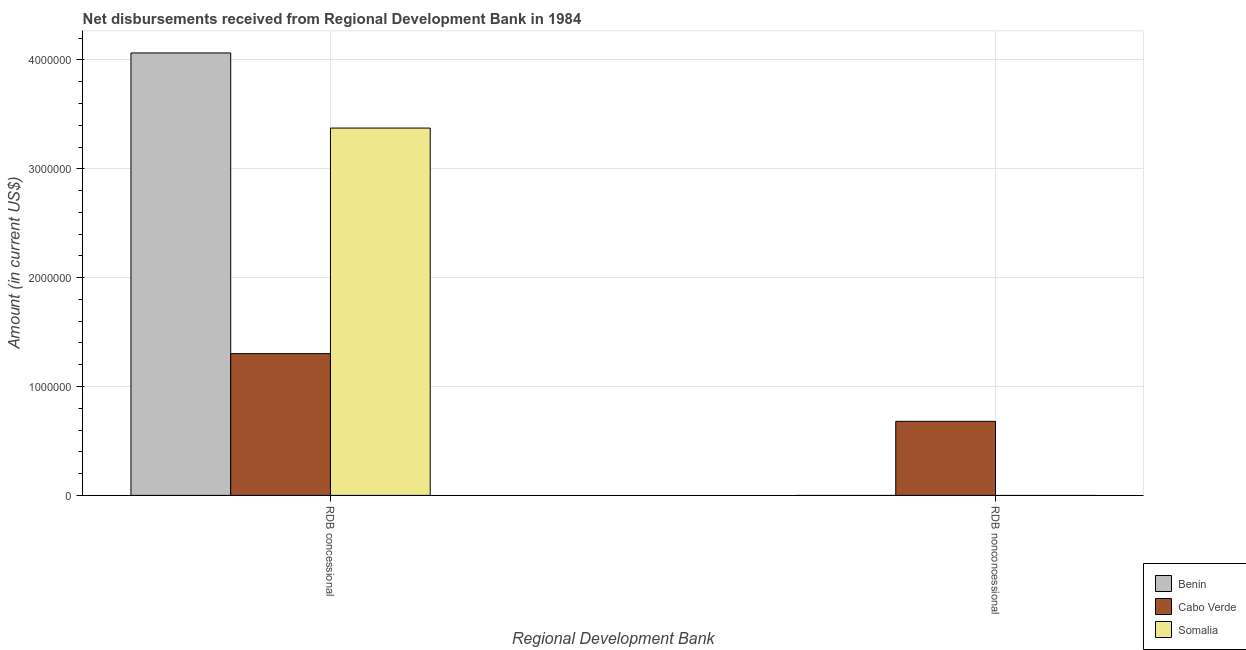How many different coloured bars are there?
Give a very brief answer. 3. Are the number of bars on each tick of the X-axis equal?
Offer a terse response. No. How many bars are there on the 1st tick from the left?
Your answer should be compact. 3. How many bars are there on the 2nd tick from the right?
Offer a very short reply. 3. What is the label of the 2nd group of bars from the left?
Offer a very short reply. RDB nonconcessional. What is the net non concessional disbursements from rdb in Cabo Verde?
Give a very brief answer. 6.80e+05. Across all countries, what is the maximum net concessional disbursements from rdb?
Offer a terse response. 4.06e+06. Across all countries, what is the minimum net concessional disbursements from rdb?
Offer a terse response. 1.30e+06. In which country was the net non concessional disbursements from rdb maximum?
Your answer should be very brief. Cabo Verde. What is the total net non concessional disbursements from rdb in the graph?
Offer a very short reply. 6.80e+05. What is the difference between the net concessional disbursements from rdb in Cabo Verde and that in Somalia?
Make the answer very short. -2.07e+06. What is the difference between the net concessional disbursements from rdb in Benin and the net non concessional disbursements from rdb in Somalia?
Keep it short and to the point. 4.06e+06. What is the average net non concessional disbursements from rdb per country?
Your answer should be compact. 2.27e+05. What is the difference between the net non concessional disbursements from rdb and net concessional disbursements from rdb in Cabo Verde?
Ensure brevity in your answer.  -6.22e+05. What is the ratio of the net concessional disbursements from rdb in Somalia to that in Cabo Verde?
Your response must be concise. 2.59. Is the net concessional disbursements from rdb in Cabo Verde less than that in Somalia?
Your response must be concise. Yes. In how many countries, is the net concessional disbursements from rdb greater than the average net concessional disbursements from rdb taken over all countries?
Your answer should be very brief. 2. How many bars are there?
Provide a short and direct response. 4. Are all the bars in the graph horizontal?
Give a very brief answer. No. How many countries are there in the graph?
Your response must be concise. 3. Does the graph contain any zero values?
Your answer should be compact. Yes. What is the title of the graph?
Make the answer very short. Net disbursements received from Regional Development Bank in 1984. Does "Romania" appear as one of the legend labels in the graph?
Your response must be concise. No. What is the label or title of the X-axis?
Give a very brief answer. Regional Development Bank. What is the Amount (in current US$) in Benin in RDB concessional?
Your answer should be very brief. 4.06e+06. What is the Amount (in current US$) of Cabo Verde in RDB concessional?
Your answer should be very brief. 1.30e+06. What is the Amount (in current US$) of Somalia in RDB concessional?
Ensure brevity in your answer.  3.37e+06. What is the Amount (in current US$) of Benin in RDB nonconcessional?
Your response must be concise. 0. What is the Amount (in current US$) of Cabo Verde in RDB nonconcessional?
Make the answer very short. 6.80e+05. What is the Amount (in current US$) in Somalia in RDB nonconcessional?
Offer a terse response. 0. Across all Regional Development Bank, what is the maximum Amount (in current US$) in Benin?
Ensure brevity in your answer.  4.06e+06. Across all Regional Development Bank, what is the maximum Amount (in current US$) in Cabo Verde?
Offer a very short reply. 1.30e+06. Across all Regional Development Bank, what is the maximum Amount (in current US$) of Somalia?
Provide a succinct answer. 3.37e+06. Across all Regional Development Bank, what is the minimum Amount (in current US$) of Benin?
Your answer should be compact. 0. Across all Regional Development Bank, what is the minimum Amount (in current US$) of Cabo Verde?
Keep it short and to the point. 6.80e+05. Across all Regional Development Bank, what is the minimum Amount (in current US$) of Somalia?
Keep it short and to the point. 0. What is the total Amount (in current US$) in Benin in the graph?
Your answer should be very brief. 4.06e+06. What is the total Amount (in current US$) of Cabo Verde in the graph?
Provide a short and direct response. 1.98e+06. What is the total Amount (in current US$) in Somalia in the graph?
Make the answer very short. 3.37e+06. What is the difference between the Amount (in current US$) of Cabo Verde in RDB concessional and that in RDB nonconcessional?
Ensure brevity in your answer.  6.22e+05. What is the difference between the Amount (in current US$) of Benin in RDB concessional and the Amount (in current US$) of Cabo Verde in RDB nonconcessional?
Ensure brevity in your answer.  3.38e+06. What is the average Amount (in current US$) of Benin per Regional Development Bank?
Your answer should be compact. 2.03e+06. What is the average Amount (in current US$) of Cabo Verde per Regional Development Bank?
Your answer should be very brief. 9.91e+05. What is the average Amount (in current US$) in Somalia per Regional Development Bank?
Provide a short and direct response. 1.69e+06. What is the difference between the Amount (in current US$) in Benin and Amount (in current US$) in Cabo Verde in RDB concessional?
Ensure brevity in your answer.  2.76e+06. What is the difference between the Amount (in current US$) in Benin and Amount (in current US$) in Somalia in RDB concessional?
Make the answer very short. 6.90e+05. What is the difference between the Amount (in current US$) of Cabo Verde and Amount (in current US$) of Somalia in RDB concessional?
Provide a succinct answer. -2.07e+06. What is the ratio of the Amount (in current US$) in Cabo Verde in RDB concessional to that in RDB nonconcessional?
Offer a terse response. 1.91. What is the difference between the highest and the second highest Amount (in current US$) of Cabo Verde?
Provide a short and direct response. 6.22e+05. What is the difference between the highest and the lowest Amount (in current US$) in Benin?
Ensure brevity in your answer.  4.06e+06. What is the difference between the highest and the lowest Amount (in current US$) in Cabo Verde?
Ensure brevity in your answer.  6.22e+05. What is the difference between the highest and the lowest Amount (in current US$) of Somalia?
Offer a terse response. 3.37e+06. 